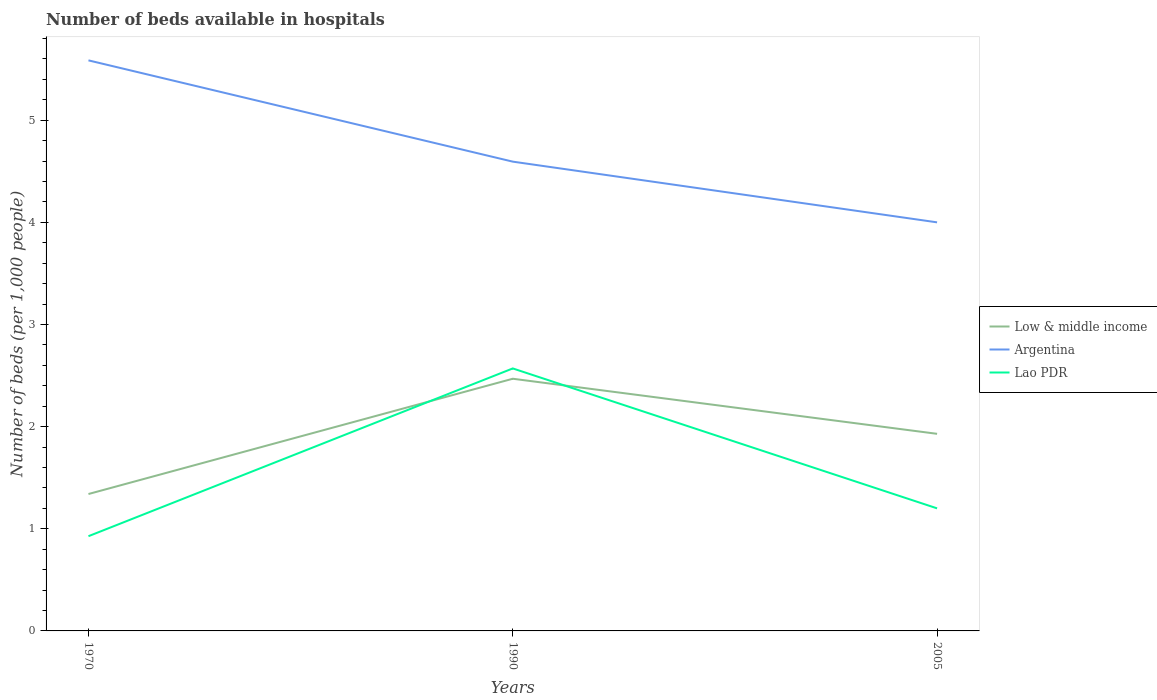In which year was the number of beds in the hospiatls of in Argentina maximum?
Ensure brevity in your answer.  2005. What is the total number of beds in the hospiatls of in Low & middle income in the graph?
Keep it short and to the point. -1.13. What is the difference between the highest and the second highest number of beds in the hospiatls of in Argentina?
Your answer should be very brief. 1.59. What is the difference between two consecutive major ticks on the Y-axis?
Offer a terse response. 1. Are the values on the major ticks of Y-axis written in scientific E-notation?
Offer a terse response. No. Does the graph contain grids?
Offer a terse response. No. What is the title of the graph?
Offer a very short reply. Number of beds available in hospitals. Does "Grenada" appear as one of the legend labels in the graph?
Ensure brevity in your answer.  No. What is the label or title of the X-axis?
Your answer should be compact. Years. What is the label or title of the Y-axis?
Offer a very short reply. Number of beds (per 1,0 people). What is the Number of beds (per 1,000 people) of Low & middle income in 1970?
Offer a terse response. 1.34. What is the Number of beds (per 1,000 people) in Argentina in 1970?
Your answer should be compact. 5.59. What is the Number of beds (per 1,000 people) in Lao PDR in 1970?
Your response must be concise. 0.93. What is the Number of beds (per 1,000 people) in Low & middle income in 1990?
Offer a very short reply. 2.47. What is the Number of beds (per 1,000 people) in Argentina in 1990?
Provide a short and direct response. 4.59. What is the Number of beds (per 1,000 people) in Lao PDR in 1990?
Ensure brevity in your answer.  2.57. What is the Number of beds (per 1,000 people) in Low & middle income in 2005?
Offer a very short reply. 1.93. Across all years, what is the maximum Number of beds (per 1,000 people) of Low & middle income?
Offer a very short reply. 2.47. Across all years, what is the maximum Number of beds (per 1,000 people) of Argentina?
Offer a terse response. 5.59. Across all years, what is the maximum Number of beds (per 1,000 people) of Lao PDR?
Keep it short and to the point. 2.57. Across all years, what is the minimum Number of beds (per 1,000 people) in Low & middle income?
Ensure brevity in your answer.  1.34. Across all years, what is the minimum Number of beds (per 1,000 people) in Argentina?
Make the answer very short. 4. Across all years, what is the minimum Number of beds (per 1,000 people) of Lao PDR?
Provide a succinct answer. 0.93. What is the total Number of beds (per 1,000 people) in Low & middle income in the graph?
Provide a succinct answer. 5.74. What is the total Number of beds (per 1,000 people) in Argentina in the graph?
Your response must be concise. 14.18. What is the total Number of beds (per 1,000 people) of Lao PDR in the graph?
Your response must be concise. 4.7. What is the difference between the Number of beds (per 1,000 people) in Low & middle income in 1970 and that in 1990?
Your answer should be very brief. -1.13. What is the difference between the Number of beds (per 1,000 people) in Lao PDR in 1970 and that in 1990?
Keep it short and to the point. -1.64. What is the difference between the Number of beds (per 1,000 people) of Low & middle income in 1970 and that in 2005?
Ensure brevity in your answer.  -0.59. What is the difference between the Number of beds (per 1,000 people) in Argentina in 1970 and that in 2005?
Keep it short and to the point. 1.59. What is the difference between the Number of beds (per 1,000 people) of Lao PDR in 1970 and that in 2005?
Offer a very short reply. -0.27. What is the difference between the Number of beds (per 1,000 people) in Low & middle income in 1990 and that in 2005?
Your answer should be very brief. 0.54. What is the difference between the Number of beds (per 1,000 people) of Argentina in 1990 and that in 2005?
Offer a terse response. 0.59. What is the difference between the Number of beds (per 1,000 people) of Lao PDR in 1990 and that in 2005?
Provide a succinct answer. 1.37. What is the difference between the Number of beds (per 1,000 people) of Low & middle income in 1970 and the Number of beds (per 1,000 people) of Argentina in 1990?
Offer a very short reply. -3.25. What is the difference between the Number of beds (per 1,000 people) of Low & middle income in 1970 and the Number of beds (per 1,000 people) of Lao PDR in 1990?
Ensure brevity in your answer.  -1.23. What is the difference between the Number of beds (per 1,000 people) in Argentina in 1970 and the Number of beds (per 1,000 people) in Lao PDR in 1990?
Your answer should be very brief. 3.02. What is the difference between the Number of beds (per 1,000 people) in Low & middle income in 1970 and the Number of beds (per 1,000 people) in Argentina in 2005?
Provide a succinct answer. -2.66. What is the difference between the Number of beds (per 1,000 people) of Low & middle income in 1970 and the Number of beds (per 1,000 people) of Lao PDR in 2005?
Ensure brevity in your answer.  0.14. What is the difference between the Number of beds (per 1,000 people) of Argentina in 1970 and the Number of beds (per 1,000 people) of Lao PDR in 2005?
Offer a terse response. 4.39. What is the difference between the Number of beds (per 1,000 people) in Low & middle income in 1990 and the Number of beds (per 1,000 people) in Argentina in 2005?
Ensure brevity in your answer.  -1.53. What is the difference between the Number of beds (per 1,000 people) of Low & middle income in 1990 and the Number of beds (per 1,000 people) of Lao PDR in 2005?
Give a very brief answer. 1.27. What is the difference between the Number of beds (per 1,000 people) in Argentina in 1990 and the Number of beds (per 1,000 people) in Lao PDR in 2005?
Keep it short and to the point. 3.39. What is the average Number of beds (per 1,000 people) in Low & middle income per year?
Ensure brevity in your answer.  1.91. What is the average Number of beds (per 1,000 people) of Argentina per year?
Give a very brief answer. 4.73. What is the average Number of beds (per 1,000 people) of Lao PDR per year?
Provide a short and direct response. 1.57. In the year 1970, what is the difference between the Number of beds (per 1,000 people) in Low & middle income and Number of beds (per 1,000 people) in Argentina?
Keep it short and to the point. -4.25. In the year 1970, what is the difference between the Number of beds (per 1,000 people) in Low & middle income and Number of beds (per 1,000 people) in Lao PDR?
Provide a succinct answer. 0.41. In the year 1970, what is the difference between the Number of beds (per 1,000 people) in Argentina and Number of beds (per 1,000 people) in Lao PDR?
Your response must be concise. 4.66. In the year 1990, what is the difference between the Number of beds (per 1,000 people) in Low & middle income and Number of beds (per 1,000 people) in Argentina?
Make the answer very short. -2.13. In the year 1990, what is the difference between the Number of beds (per 1,000 people) of Low & middle income and Number of beds (per 1,000 people) of Lao PDR?
Give a very brief answer. -0.1. In the year 1990, what is the difference between the Number of beds (per 1,000 people) of Argentina and Number of beds (per 1,000 people) of Lao PDR?
Your answer should be very brief. 2.02. In the year 2005, what is the difference between the Number of beds (per 1,000 people) in Low & middle income and Number of beds (per 1,000 people) in Argentina?
Offer a terse response. -2.07. In the year 2005, what is the difference between the Number of beds (per 1,000 people) in Low & middle income and Number of beds (per 1,000 people) in Lao PDR?
Make the answer very short. 0.73. What is the ratio of the Number of beds (per 1,000 people) in Low & middle income in 1970 to that in 1990?
Keep it short and to the point. 0.54. What is the ratio of the Number of beds (per 1,000 people) of Argentina in 1970 to that in 1990?
Give a very brief answer. 1.22. What is the ratio of the Number of beds (per 1,000 people) in Lao PDR in 1970 to that in 1990?
Give a very brief answer. 0.36. What is the ratio of the Number of beds (per 1,000 people) in Low & middle income in 1970 to that in 2005?
Your response must be concise. 0.69. What is the ratio of the Number of beds (per 1,000 people) of Argentina in 1970 to that in 2005?
Ensure brevity in your answer.  1.4. What is the ratio of the Number of beds (per 1,000 people) in Lao PDR in 1970 to that in 2005?
Ensure brevity in your answer.  0.77. What is the ratio of the Number of beds (per 1,000 people) in Low & middle income in 1990 to that in 2005?
Keep it short and to the point. 1.28. What is the ratio of the Number of beds (per 1,000 people) in Argentina in 1990 to that in 2005?
Your answer should be compact. 1.15. What is the ratio of the Number of beds (per 1,000 people) of Lao PDR in 1990 to that in 2005?
Ensure brevity in your answer.  2.14. What is the difference between the highest and the second highest Number of beds (per 1,000 people) of Low & middle income?
Your answer should be compact. 0.54. What is the difference between the highest and the second highest Number of beds (per 1,000 people) of Argentina?
Offer a very short reply. 0.99. What is the difference between the highest and the second highest Number of beds (per 1,000 people) in Lao PDR?
Your answer should be compact. 1.37. What is the difference between the highest and the lowest Number of beds (per 1,000 people) in Low & middle income?
Offer a terse response. 1.13. What is the difference between the highest and the lowest Number of beds (per 1,000 people) of Argentina?
Offer a terse response. 1.59. What is the difference between the highest and the lowest Number of beds (per 1,000 people) in Lao PDR?
Make the answer very short. 1.64. 